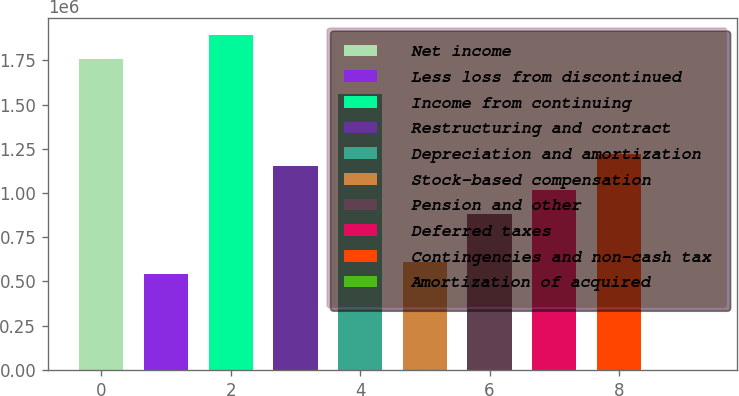<chart> <loc_0><loc_0><loc_500><loc_500><bar_chart><fcel>Net income<fcel>Less loss from discontinued<fcel>Income from continuing<fcel>Restructuring and contract<fcel>Depreciation and amortization<fcel>Stock-based compensation<fcel>Pension and other<fcel>Deferred taxes<fcel>Contingencies and non-cash tax<fcel>Amortization of acquired<nl><fcel>1.75988e+06<fcel>541641<fcel>1.89523e+06<fcel>1.15076e+06<fcel>1.55684e+06<fcel>609320<fcel>880039<fcel>1.0154e+06<fcel>1.21844e+06<fcel>203<nl></chart> 